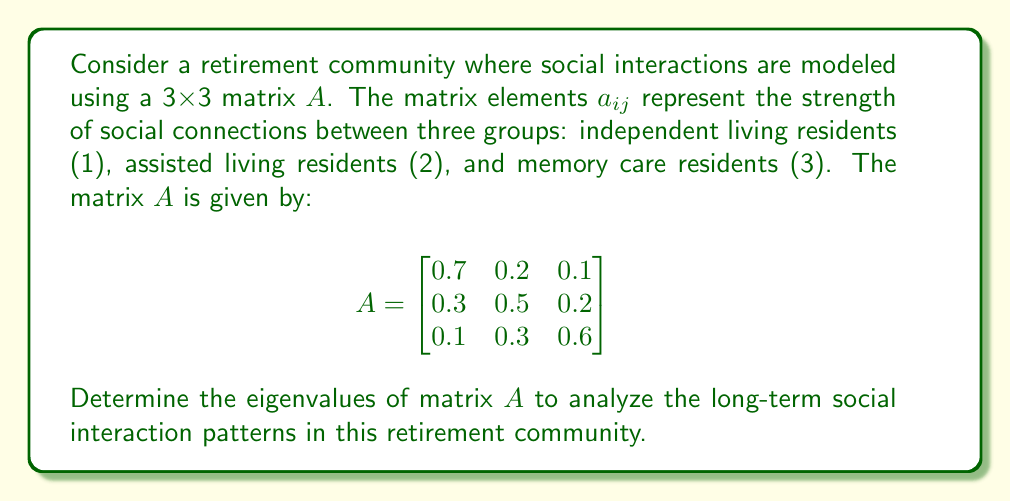Help me with this question. To find the eigenvalues of matrix $A$, we need to solve the characteristic equation:

$\det(A - \lambda I) = 0$

Where $I$ is the 3x3 identity matrix and $\lambda$ represents the eigenvalues.

Step 1: Set up the characteristic equation:

$$\det\begin{bmatrix}
0.7-\lambda & 0.2 & 0.1 \\
0.3 & 0.5-\lambda & 0.2 \\
0.1 & 0.3 & 0.6-\lambda
\end{bmatrix} = 0$$

Step 2: Expand the determinant:

$(0.7-\lambda)[(0.5-\lambda)(0.6-\lambda) - 0.06] - 0.2[0.3(0.6-\lambda) - 0.02] + 0.1[0.3(0.5-\lambda) - 0.06] = 0$

Step 3: Simplify and collect terms:

$-\lambda^3 + 1.8\lambda^2 - 0.83\lambda + 0.1 = 0$

Step 4: Solve the cubic equation. This can be done using various methods such as the cubic formula or numerical methods. In this case, we can factor the equation:

$-(\lambda - 1)(\lambda - 0.5)(\lambda - 0.3) = 0$

Step 5: Identify the eigenvalues:

$\lambda_1 = 1$
$\lambda_2 = 0.5$
$\lambda_3 = 0.3$

These eigenvalues provide insights into the long-term social interaction patterns in the retirement community. The largest eigenvalue (1) indicates the dominant interaction pattern, while the other eigenvalues represent secondary patterns.
Answer: The eigenvalues of matrix $A$ are:
$\lambda_1 = 1$, $\lambda_2 = 0.5$, and $\lambda_3 = 0.3$ 